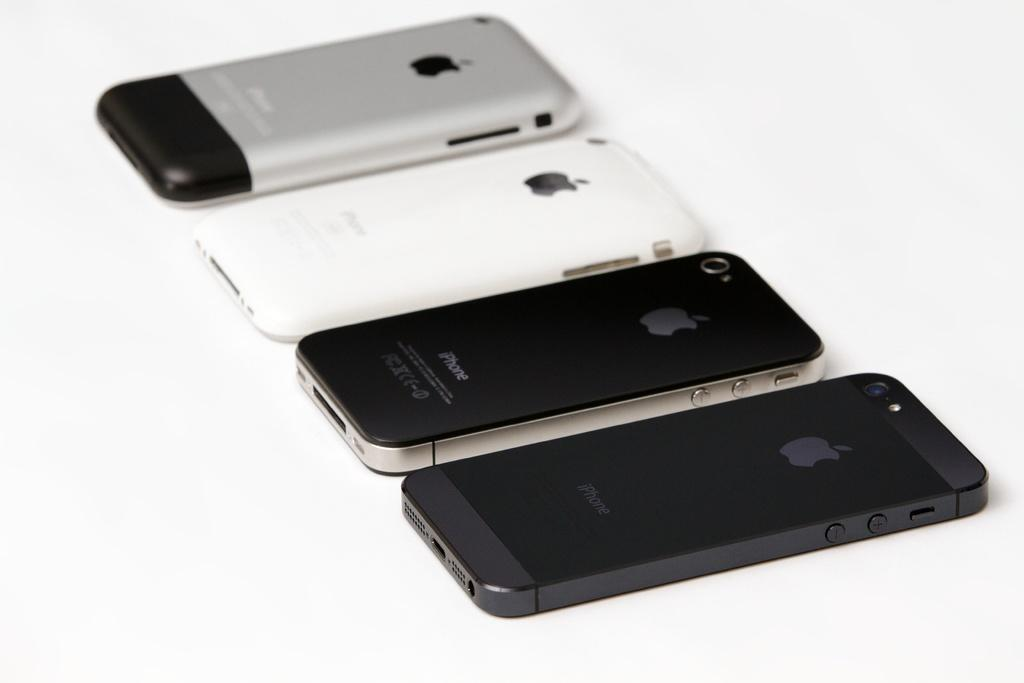How many earphones are visible in the image? There are four earphones in the image. What is the color of the surface on which the earphones are placed? The earphones are placed on a white color surface. What are the colors of the earphones? Two of the earphones are white in color, one is black, and one is gray. Are there any earphones with a mix of colors? Yes, one of the earphones has a part that is black in color. What type of kitty can be seen playing with a structure in the image? There is no kitty or structure present in the image; it only features earphones placed on a white surface. What type of sheet is covering the earphones in the image? There is no sheet covering the earphones in the image; they are placed directly on the white surface. 